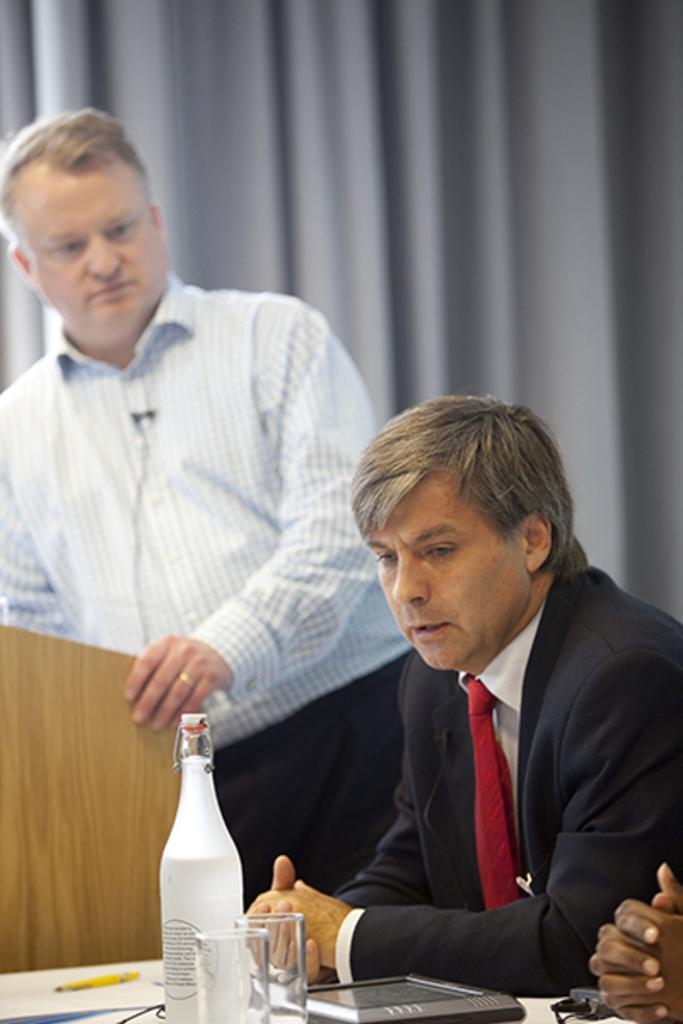In one or two sentences, can you explain what this image depicts? A person wearing a black dress is sitting. Near to him another person wearing a white shirt is standing. In front of him there is a podium. There is a table. On the table there are glasses, bottle tab and a pen. In the background there is a gray curtain. 